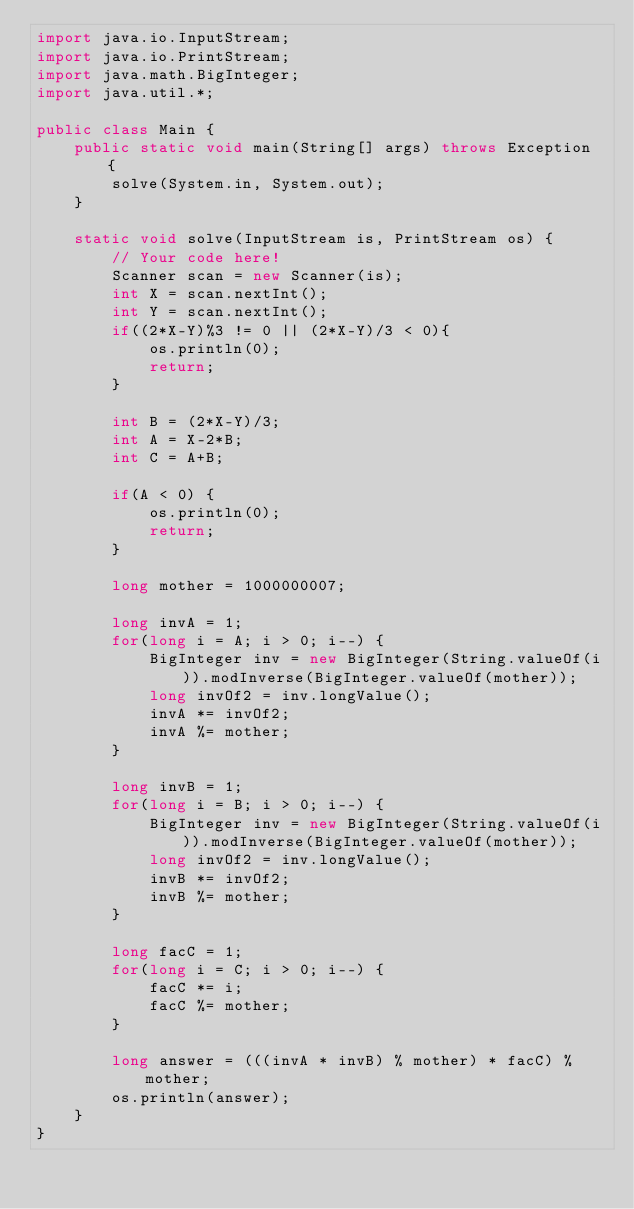<code> <loc_0><loc_0><loc_500><loc_500><_Java_>import java.io.InputStream;
import java.io.PrintStream;
import java.math.BigInteger;
import java.util.*;

public class Main {
    public static void main(String[] args) throws Exception {
        solve(System.in, System.out);
    }

    static void solve(InputStream is, PrintStream os) {
        // Your code here!
        Scanner scan = new Scanner(is);
        int X = scan.nextInt();
        int Y = scan.nextInt();
        if((2*X-Y)%3 != 0 || (2*X-Y)/3 < 0){
            os.println(0);
            return;
        }

        int B = (2*X-Y)/3;
        int A = X-2*B;
        int C = A+B;

        if(A < 0) {
            os.println(0);
            return;
        }

        long mother = 1000000007;

        long invA = 1;
        for(long i = A; i > 0; i--) {
            BigInteger inv = new BigInteger(String.valueOf(i)).modInverse(BigInteger.valueOf(mother));
            long invOf2 = inv.longValue();
            invA *= invOf2;
            invA %= mother;
        }

        long invB = 1;
        for(long i = B; i > 0; i--) {
            BigInteger inv = new BigInteger(String.valueOf(i)).modInverse(BigInteger.valueOf(mother));
            long invOf2 = inv.longValue();
            invB *= invOf2;
            invB %= mother;
        }

        long facC = 1;
        for(long i = C; i > 0; i--) {
            facC *= i;
            facC %= mother;
        }

        long answer = (((invA * invB) % mother) * facC) % mother;
        os.println(answer);
    }
}</code> 